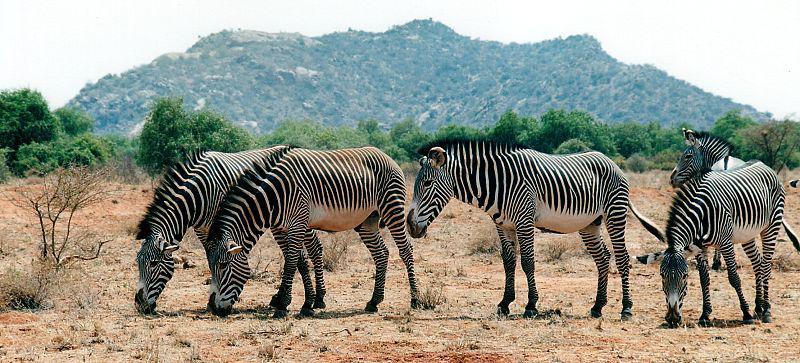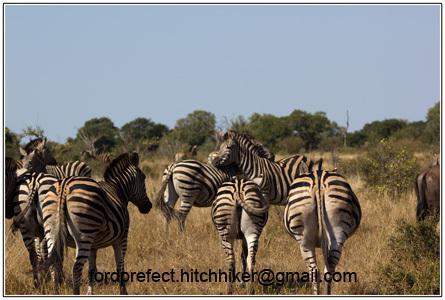The first image is the image on the left, the second image is the image on the right. Analyze the images presented: Is the assertion "One image contains multiple rear-facing zebra in the foreground, and all images show only dry ground with no non-zebra animal herds visible." valid? Answer yes or no. Yes. The first image is the image on the left, the second image is the image on the right. For the images displayed, is the sentence "There are trees visible in both images." factually correct? Answer yes or no. Yes. 